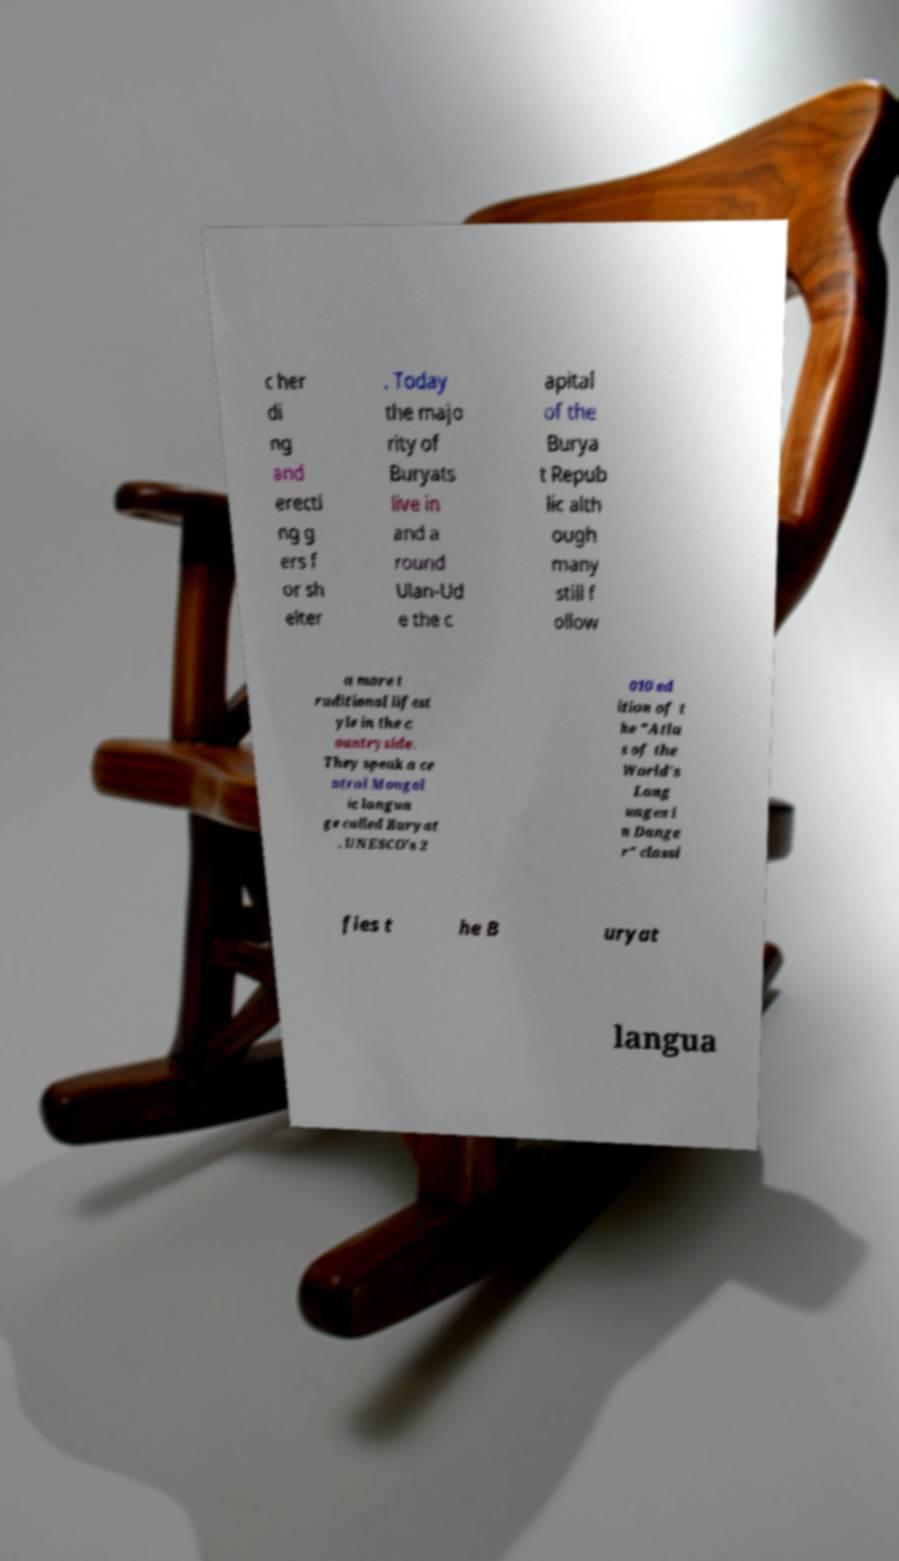Can you read and provide the text displayed in the image?This photo seems to have some interesting text. Can you extract and type it out for me? c her di ng and erecti ng g ers f or sh elter . Today the majo rity of Buryats live in and a round Ulan-Ud e the c apital of the Burya t Repub lic alth ough many still f ollow a more t raditional lifest yle in the c ountryside. They speak a ce ntral Mongol ic langua ge called Buryat . UNESCO's 2 010 ed ition of t he "Atla s of the World's Lang uages i n Dange r" classi fies t he B uryat langua 